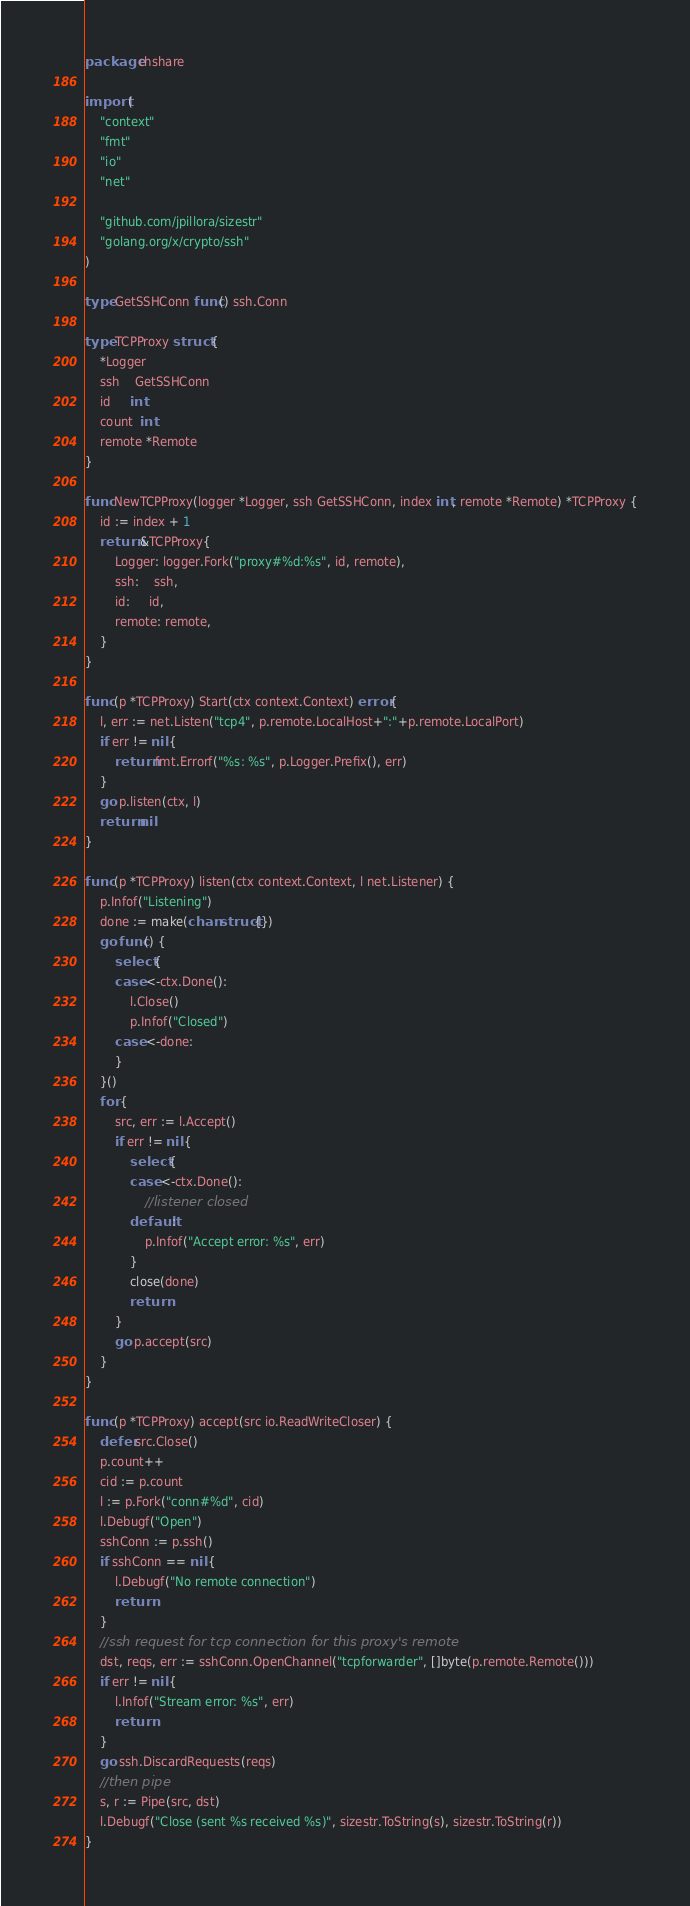<code> <loc_0><loc_0><loc_500><loc_500><_Go_>package chshare

import (
	"context"
	"fmt"
	"io"
	"net"

	"github.com/jpillora/sizestr"
	"golang.org/x/crypto/ssh"
)

type GetSSHConn func() ssh.Conn

type TCPProxy struct {
	*Logger
	ssh    GetSSHConn
	id     int
	count  int
	remote *Remote
}

func NewTCPProxy(logger *Logger, ssh GetSSHConn, index int, remote *Remote) *TCPProxy {
	id := index + 1
	return &TCPProxy{
		Logger: logger.Fork("proxy#%d:%s", id, remote),
		ssh:    ssh,
		id:     id,
		remote: remote,
	}
}

func (p *TCPProxy) Start(ctx context.Context) error {
	l, err := net.Listen("tcp4", p.remote.LocalHost+":"+p.remote.LocalPort)
	if err != nil {
		return fmt.Errorf("%s: %s", p.Logger.Prefix(), err)
	}
	go p.listen(ctx, l)
	return nil
}

func (p *TCPProxy) listen(ctx context.Context, l net.Listener) {
	p.Infof("Listening")
	done := make(chan struct{})
	go func() {
		select {
		case <-ctx.Done():
			l.Close()
			p.Infof("Closed")
		case <-done:
		}
	}()
	for {
		src, err := l.Accept()
		if err != nil {
			select {
			case <-ctx.Done():
				//listener closed
			default:
				p.Infof("Accept error: %s", err)
			}
			close(done)
			return
		}
		go p.accept(src)
	}
}

func (p *TCPProxy) accept(src io.ReadWriteCloser) {
	defer src.Close()
	p.count++
	cid := p.count
	l := p.Fork("conn#%d", cid)
	l.Debugf("Open")
	sshConn := p.ssh()
	if sshConn == nil {
		l.Debugf("No remote connection")
		return
	}
	//ssh request for tcp connection for this proxy's remote
	dst, reqs, err := sshConn.OpenChannel("tcpforwarder", []byte(p.remote.Remote()))
	if err != nil {
		l.Infof("Stream error: %s", err)
		return
	}
	go ssh.DiscardRequests(reqs)
	//then pipe
	s, r := Pipe(src, dst)
	l.Debugf("Close (sent %s received %s)", sizestr.ToString(s), sizestr.ToString(r))
}
</code> 